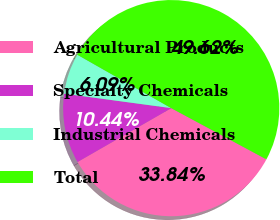<chart> <loc_0><loc_0><loc_500><loc_500><pie_chart><fcel>Agricultural Products<fcel>Specialty Chemicals<fcel>Industrial Chemicals<fcel>Total<nl><fcel>33.84%<fcel>10.44%<fcel>6.09%<fcel>49.62%<nl></chart> 